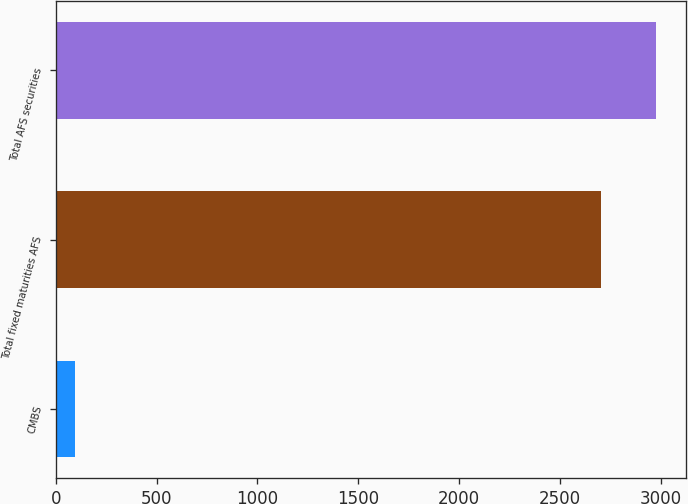Convert chart to OTSL. <chart><loc_0><loc_0><loc_500><loc_500><bar_chart><fcel>CMBS<fcel>Total fixed maturities AFS<fcel>Total AFS securities<nl><fcel>97<fcel>2704<fcel>2974.3<nl></chart> 